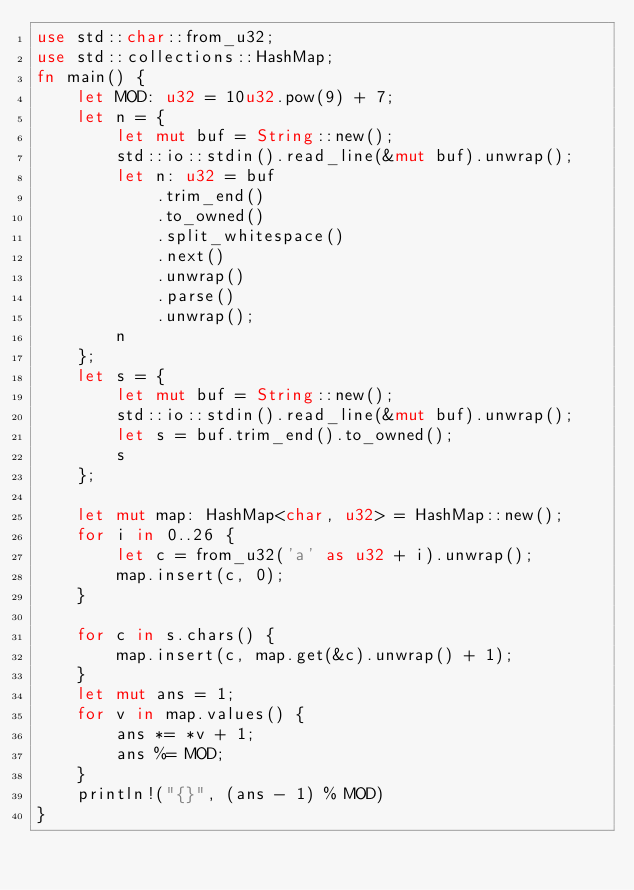Convert code to text. <code><loc_0><loc_0><loc_500><loc_500><_Rust_>use std::char::from_u32;
use std::collections::HashMap;
fn main() {
    let MOD: u32 = 10u32.pow(9) + 7;
    let n = {
        let mut buf = String::new();
        std::io::stdin().read_line(&mut buf).unwrap();
        let n: u32 = buf
            .trim_end()
            .to_owned()
            .split_whitespace()
            .next()
            .unwrap()
            .parse()
            .unwrap();
        n
    };
    let s = {
        let mut buf = String::new();
        std::io::stdin().read_line(&mut buf).unwrap();
        let s = buf.trim_end().to_owned();
        s
    };

    let mut map: HashMap<char, u32> = HashMap::new();
    for i in 0..26 {
        let c = from_u32('a' as u32 + i).unwrap();
        map.insert(c, 0);
    }

    for c in s.chars() {
        map.insert(c, map.get(&c).unwrap() + 1);
    }
    let mut ans = 1;
    for v in map.values() {
        ans *= *v + 1;
        ans %= MOD;
    }
    println!("{}", (ans - 1) % MOD)
}
</code> 